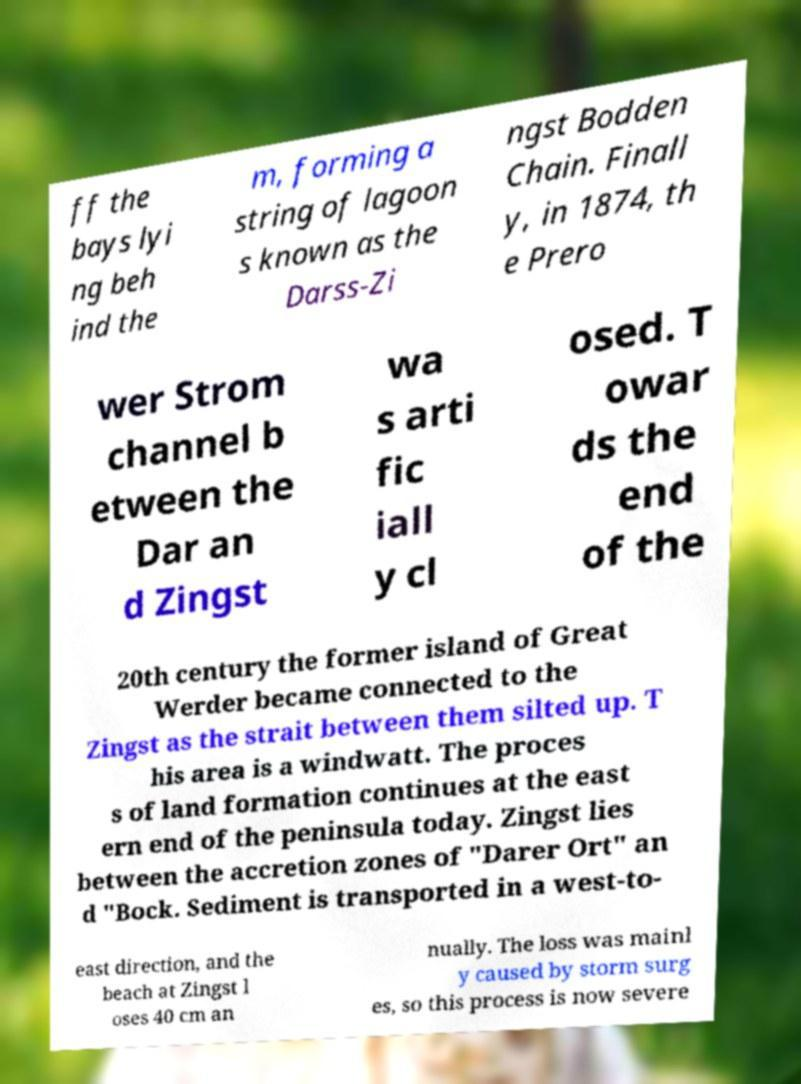What messages or text are displayed in this image? I need them in a readable, typed format. ff the bays lyi ng beh ind the m, forming a string of lagoon s known as the Darss-Zi ngst Bodden Chain. Finall y, in 1874, th e Prero wer Strom channel b etween the Dar an d Zingst wa s arti fic iall y cl osed. T owar ds the end of the 20th century the former island of Great Werder became connected to the Zingst as the strait between them silted up. T his area is a windwatt. The proces s of land formation continues at the east ern end of the peninsula today. Zingst lies between the accretion zones of "Darer Ort" an d "Bock. Sediment is transported in a west-to- east direction, and the beach at Zingst l oses 40 cm an nually. The loss was mainl y caused by storm surg es, so this process is now severe 